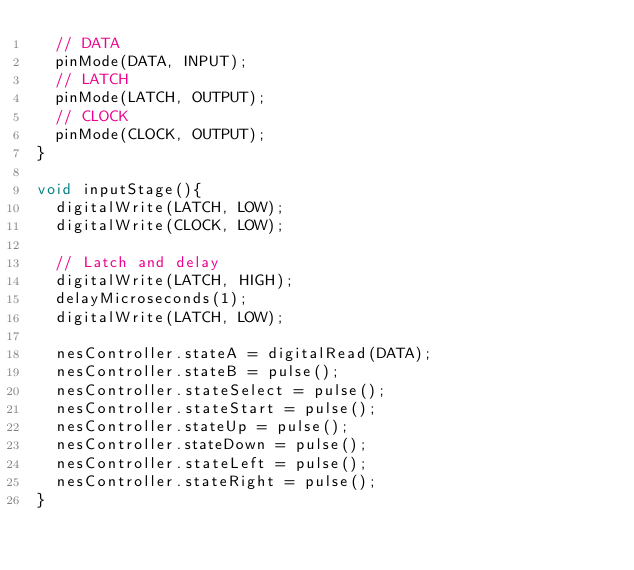Convert code to text. <code><loc_0><loc_0><loc_500><loc_500><_C_>  // DATA
  pinMode(DATA, INPUT);
  // LATCH
  pinMode(LATCH, OUTPUT);
  // CLOCK
  pinMode(CLOCK, OUTPUT);
}

void inputStage(){
  digitalWrite(LATCH, LOW);
  digitalWrite(CLOCK, LOW);

  // Latch and delay
  digitalWrite(LATCH, HIGH);
  delayMicroseconds(1);
  digitalWrite(LATCH, LOW);

  nesController.stateA = digitalRead(DATA);
  nesController.stateB = pulse();
  nesController.stateSelect = pulse();
  nesController.stateStart = pulse();
  nesController.stateUp = pulse();
  nesController.stateDown = pulse();
  nesController.stateLeft = pulse();
  nesController.stateRight = pulse();
}
</code> 